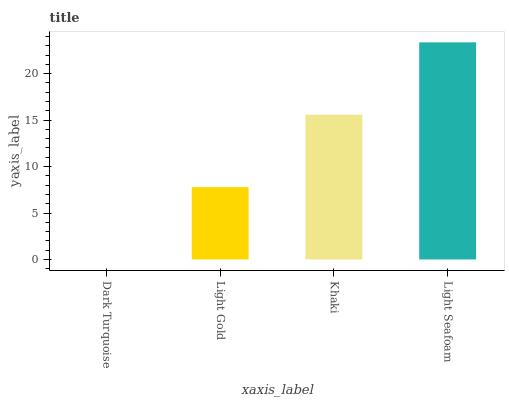Is Dark Turquoise the minimum?
Answer yes or no. Yes. Is Light Seafoam the maximum?
Answer yes or no. Yes. Is Light Gold the minimum?
Answer yes or no. No. Is Light Gold the maximum?
Answer yes or no. No. Is Light Gold greater than Dark Turquoise?
Answer yes or no. Yes. Is Dark Turquoise less than Light Gold?
Answer yes or no. Yes. Is Dark Turquoise greater than Light Gold?
Answer yes or no. No. Is Light Gold less than Dark Turquoise?
Answer yes or no. No. Is Khaki the high median?
Answer yes or no. Yes. Is Light Gold the low median?
Answer yes or no. Yes. Is Light Seafoam the high median?
Answer yes or no. No. Is Dark Turquoise the low median?
Answer yes or no. No. 